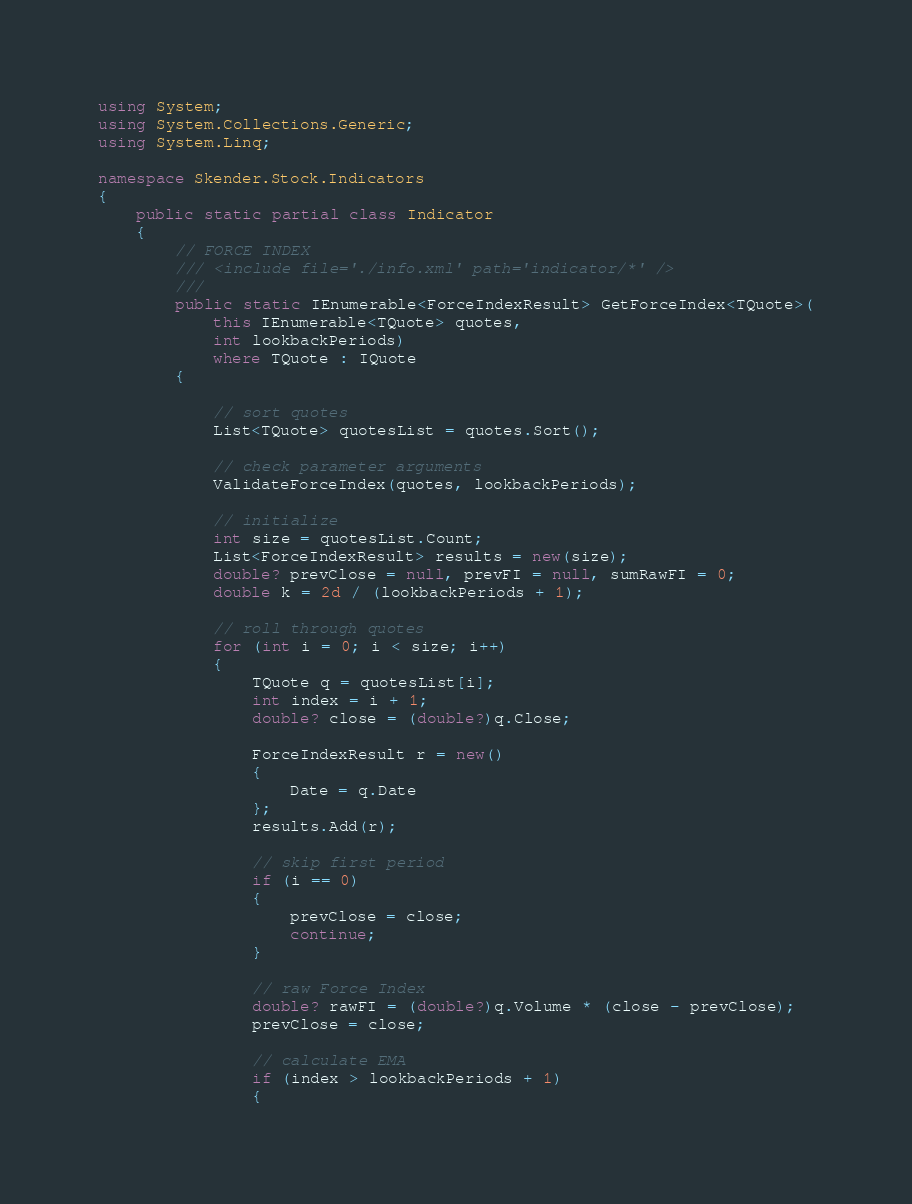Convert code to text. <code><loc_0><loc_0><loc_500><loc_500><_C#_>using System;
using System.Collections.Generic;
using System.Linq;

namespace Skender.Stock.Indicators
{
    public static partial class Indicator
    {
        // FORCE INDEX
        /// <include file='./info.xml' path='indicator/*' />
        /// 
        public static IEnumerable<ForceIndexResult> GetForceIndex<TQuote>(
            this IEnumerable<TQuote> quotes,
            int lookbackPeriods)
            where TQuote : IQuote
        {

            // sort quotes
            List<TQuote> quotesList = quotes.Sort();

            // check parameter arguments
            ValidateForceIndex(quotes, lookbackPeriods);

            // initialize
            int size = quotesList.Count;
            List<ForceIndexResult> results = new(size);
            double? prevClose = null, prevFI = null, sumRawFI = 0;
            double k = 2d / (lookbackPeriods + 1);

            // roll through quotes
            for (int i = 0; i < size; i++)
            {
                TQuote q = quotesList[i];
                int index = i + 1;
                double? close = (double?)q.Close;

                ForceIndexResult r = new()
                {
                    Date = q.Date
                };
                results.Add(r);

                // skip first period
                if (i == 0)
                {
                    prevClose = close;
                    continue;
                }

                // raw Force Index
                double? rawFI = (double?)q.Volume * (close - prevClose);
                prevClose = close;

                // calculate EMA
                if (index > lookbackPeriods + 1)
                {</code> 